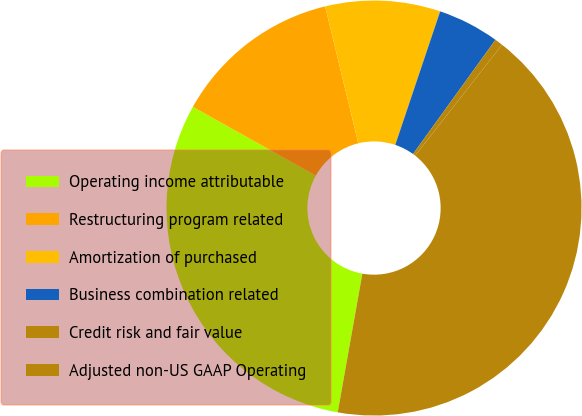<chart> <loc_0><loc_0><loc_500><loc_500><pie_chart><fcel>Operating income attributable<fcel>Restructuring program related<fcel>Amortization of purchased<fcel>Business combination related<fcel>Credit risk and fair value<fcel>Adjusted non-US GAAP Operating<nl><fcel>30.31%<fcel>13.11%<fcel>8.95%<fcel>4.79%<fcel>0.63%<fcel>42.22%<nl></chart> 